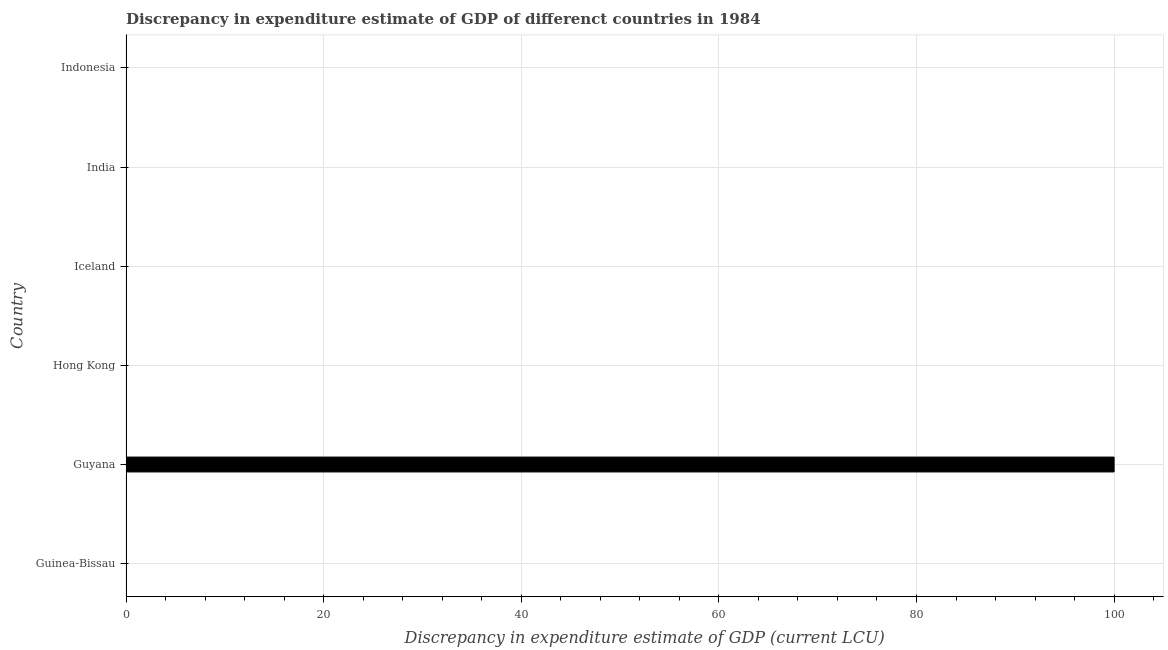Does the graph contain any zero values?
Offer a very short reply. Yes. Does the graph contain grids?
Give a very brief answer. Yes. What is the title of the graph?
Offer a very short reply. Discrepancy in expenditure estimate of GDP of differenct countries in 1984. What is the label or title of the X-axis?
Provide a succinct answer. Discrepancy in expenditure estimate of GDP (current LCU). What is the discrepancy in expenditure estimate of gdp in India?
Provide a succinct answer. 0. Across all countries, what is the maximum discrepancy in expenditure estimate of gdp?
Your answer should be compact. 100. In which country was the discrepancy in expenditure estimate of gdp maximum?
Offer a terse response. Guyana. What is the average discrepancy in expenditure estimate of gdp per country?
Keep it short and to the point. 16.67. In how many countries, is the discrepancy in expenditure estimate of gdp greater than 20 LCU?
Offer a very short reply. 1. What is the difference between the highest and the lowest discrepancy in expenditure estimate of gdp?
Provide a short and direct response. 100. In how many countries, is the discrepancy in expenditure estimate of gdp greater than the average discrepancy in expenditure estimate of gdp taken over all countries?
Give a very brief answer. 1. How many bars are there?
Keep it short and to the point. 1. Are all the bars in the graph horizontal?
Offer a terse response. Yes. What is the Discrepancy in expenditure estimate of GDP (current LCU) of Guinea-Bissau?
Provide a short and direct response. 0. What is the Discrepancy in expenditure estimate of GDP (current LCU) of Hong Kong?
Give a very brief answer. 0. What is the Discrepancy in expenditure estimate of GDP (current LCU) of India?
Offer a terse response. 0. What is the Discrepancy in expenditure estimate of GDP (current LCU) in Indonesia?
Keep it short and to the point. 0. 